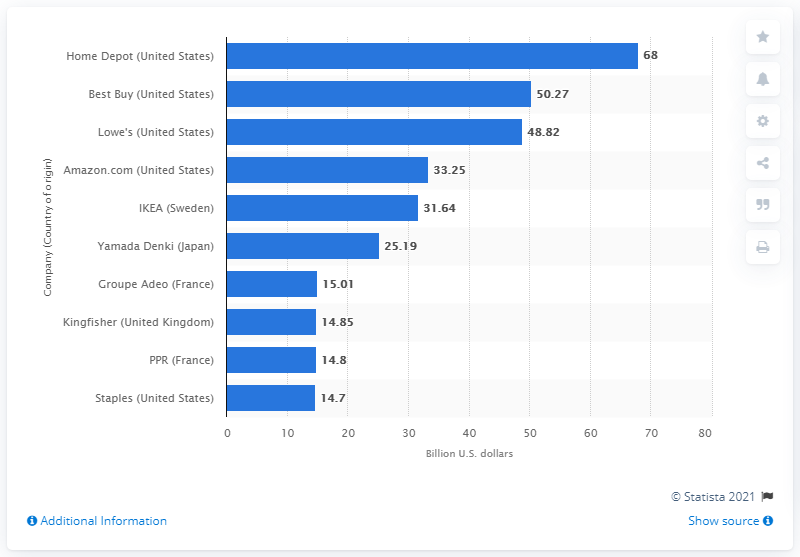Outline some significant characteristics in this image. Home Depot reported sales of $68 billion in 2010. 